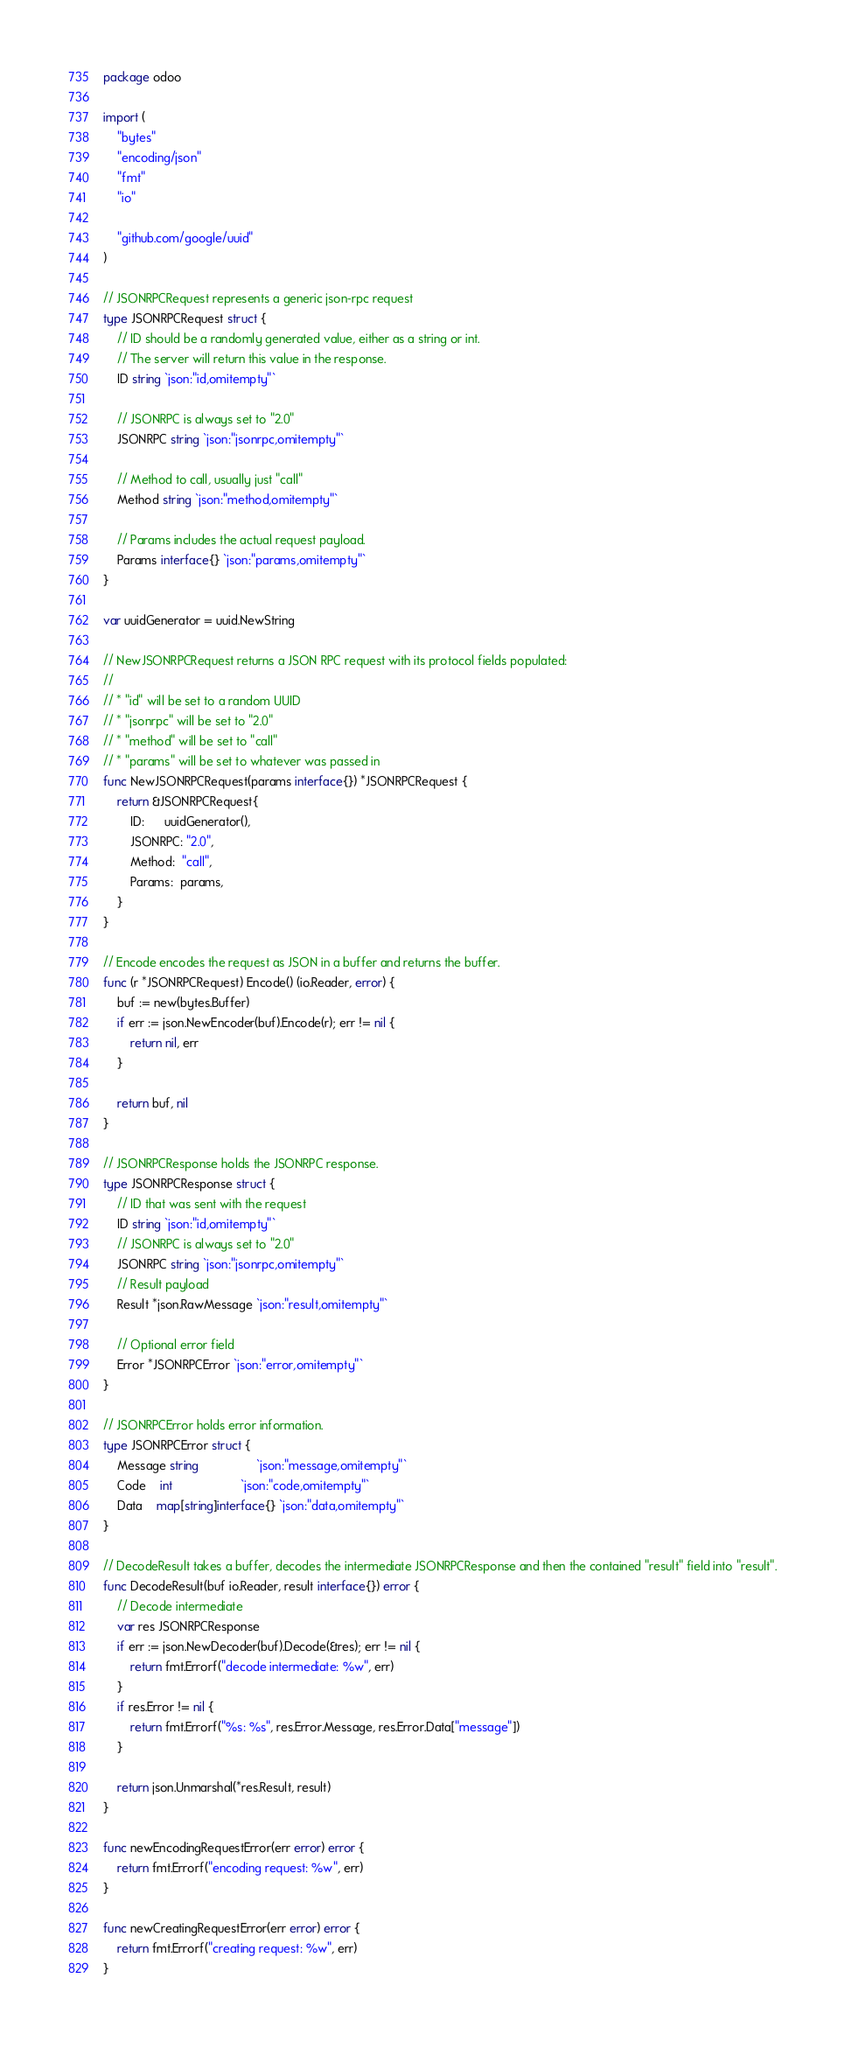Convert code to text. <code><loc_0><loc_0><loc_500><loc_500><_Go_>package odoo

import (
	"bytes"
	"encoding/json"
	"fmt"
	"io"

	"github.com/google/uuid"
)

// JSONRPCRequest represents a generic json-rpc request
type JSONRPCRequest struct {
	// ID should be a randomly generated value, either as a string or int.
	// The server will return this value in the response.
	ID string `json:"id,omitempty"`

	// JSONRPC is always set to "2.0"
	JSONRPC string `json:"jsonrpc,omitempty"`

	// Method to call, usually just "call"
	Method string `json:"method,omitempty"`

	// Params includes the actual request payload.
	Params interface{} `json:"params,omitempty"`
}

var uuidGenerator = uuid.NewString

// NewJSONRPCRequest returns a JSON RPC request with its protocol fields populated:
//
// * "id" will be set to a random UUID
// * "jsonrpc" will be set to "2.0"
// * "method" will be set to "call"
// * "params" will be set to whatever was passed in
func NewJSONRPCRequest(params interface{}) *JSONRPCRequest {
	return &JSONRPCRequest{
		ID:      uuidGenerator(),
		JSONRPC: "2.0",
		Method:  "call",
		Params:  params,
	}
}

// Encode encodes the request as JSON in a buffer and returns the buffer.
func (r *JSONRPCRequest) Encode() (io.Reader, error) {
	buf := new(bytes.Buffer)
	if err := json.NewEncoder(buf).Encode(r); err != nil {
		return nil, err
	}

	return buf, nil
}

// JSONRPCResponse holds the JSONRPC response.
type JSONRPCResponse struct {
	// ID that was sent with the request
	ID string `json:"id,omitempty"`
	// JSONRPC is always set to "2.0"
	JSONRPC string `json:"jsonrpc,omitempty"`
	// Result payload
	Result *json.RawMessage `json:"result,omitempty"`

	// Optional error field
	Error *JSONRPCError `json:"error,omitempty"`
}

// JSONRPCError holds error information.
type JSONRPCError struct {
	Message string                 `json:"message,omitempty"`
	Code    int                    `json:"code,omitempty"`
	Data    map[string]interface{} `json:"data,omitempty"`
}

// DecodeResult takes a buffer, decodes the intermediate JSONRPCResponse and then the contained "result" field into "result".
func DecodeResult(buf io.Reader, result interface{}) error {
	// Decode intermediate
	var res JSONRPCResponse
	if err := json.NewDecoder(buf).Decode(&res); err != nil {
		return fmt.Errorf("decode intermediate: %w", err)
	}
	if res.Error != nil {
		return fmt.Errorf("%s: %s", res.Error.Message, res.Error.Data["message"])
	}

	return json.Unmarshal(*res.Result, result)
}

func newEncodingRequestError(err error) error {
	return fmt.Errorf("encoding request: %w", err)
}

func newCreatingRequestError(err error) error {
	return fmt.Errorf("creating request: %w", err)
}
</code> 